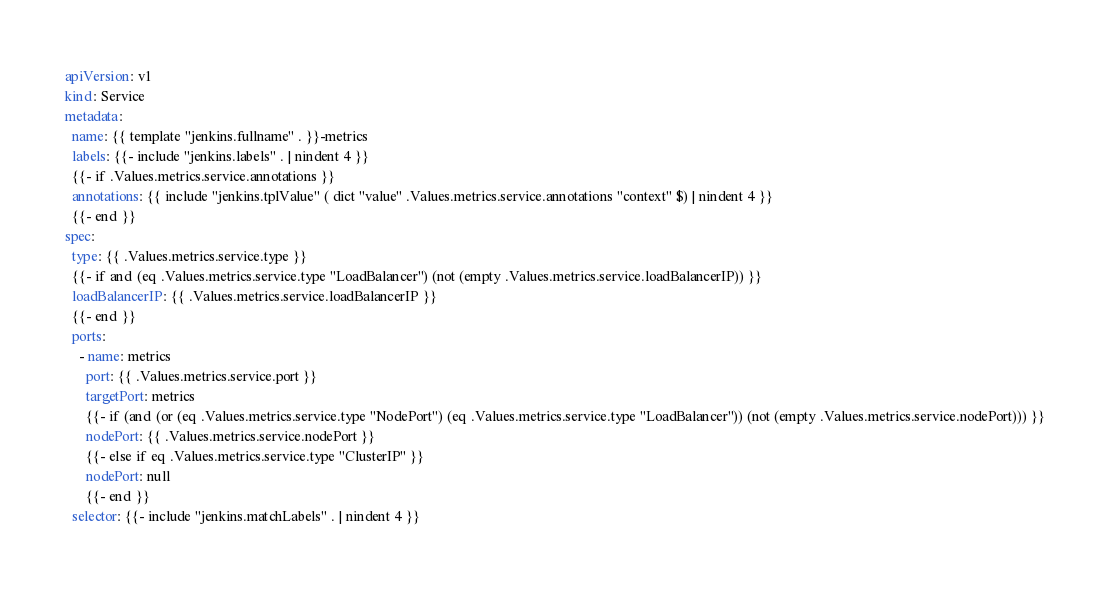Convert code to text. <code><loc_0><loc_0><loc_500><loc_500><_YAML_>apiVersion: v1
kind: Service
metadata:
  name: {{ template "jenkins.fullname" . }}-metrics
  labels: {{- include "jenkins.labels" . | nindent 4 }}
  {{- if .Values.metrics.service.annotations }}
  annotations: {{ include "jenkins.tplValue" ( dict "value" .Values.metrics.service.annotations "context" $) | nindent 4 }}
  {{- end }}
spec:
  type: {{ .Values.metrics.service.type }}
  {{- if and (eq .Values.metrics.service.type "LoadBalancer") (not (empty .Values.metrics.service.loadBalancerIP)) }}
  loadBalancerIP: {{ .Values.metrics.service.loadBalancerIP }}
  {{- end }}
  ports:
    - name: metrics
      port: {{ .Values.metrics.service.port }}
      targetPort: metrics
      {{- if (and (or (eq .Values.metrics.service.type "NodePort") (eq .Values.metrics.service.type "LoadBalancer")) (not (empty .Values.metrics.service.nodePort))) }}
      nodePort: {{ .Values.metrics.service.nodePort }}
      {{- else if eq .Values.metrics.service.type "ClusterIP" }}
      nodePort: null
      {{- end }}
  selector: {{- include "jenkins.matchLabels" . | nindent 4 }}
</code> 